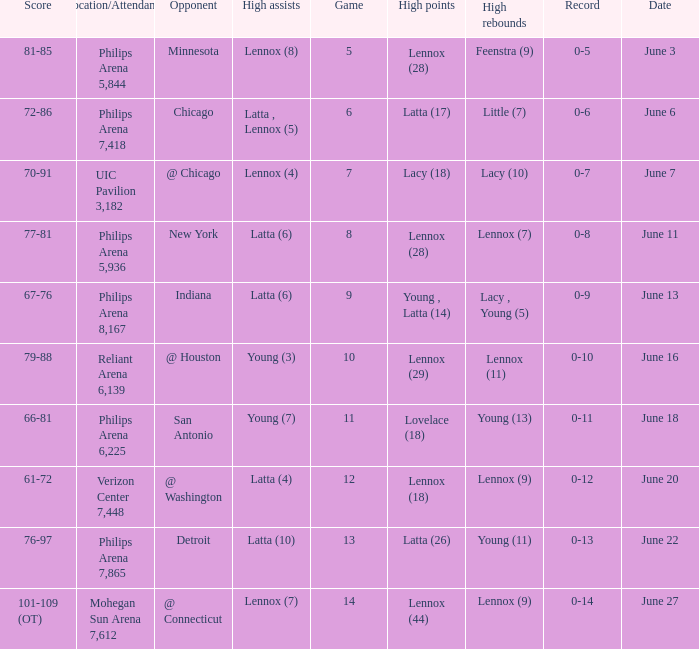What stadium hosted the June 7 game and how many visitors were there? UIC Pavilion 3,182. 